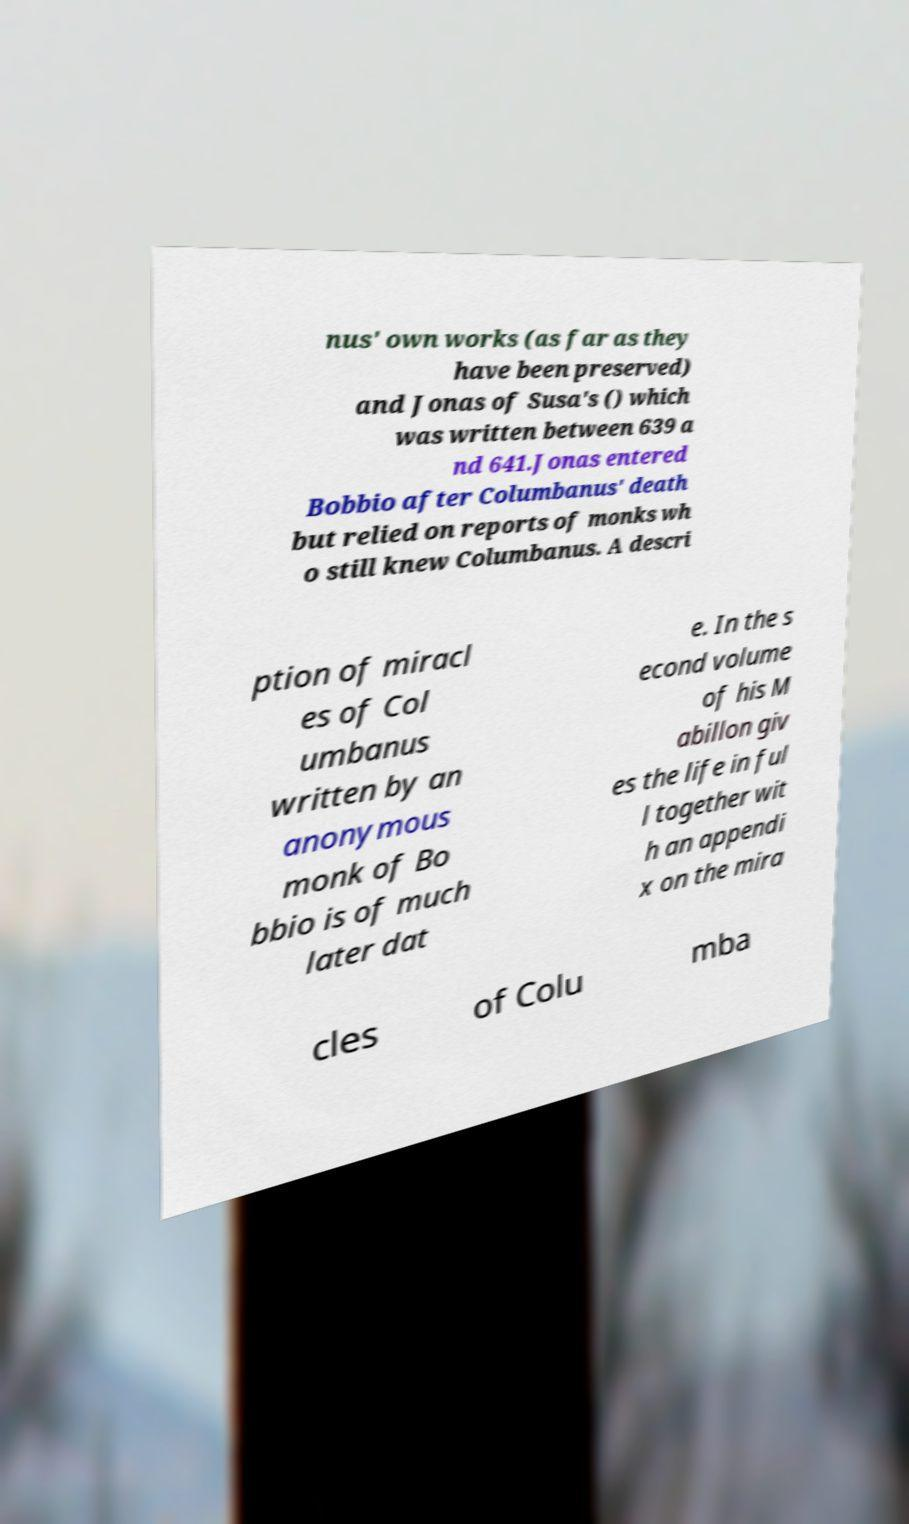There's text embedded in this image that I need extracted. Can you transcribe it verbatim? nus' own works (as far as they have been preserved) and Jonas of Susa's () which was written between 639 a nd 641.Jonas entered Bobbio after Columbanus' death but relied on reports of monks wh o still knew Columbanus. A descri ption of miracl es of Col umbanus written by an anonymous monk of Bo bbio is of much later dat e. In the s econd volume of his M abillon giv es the life in ful l together wit h an appendi x on the mira cles of Colu mba 